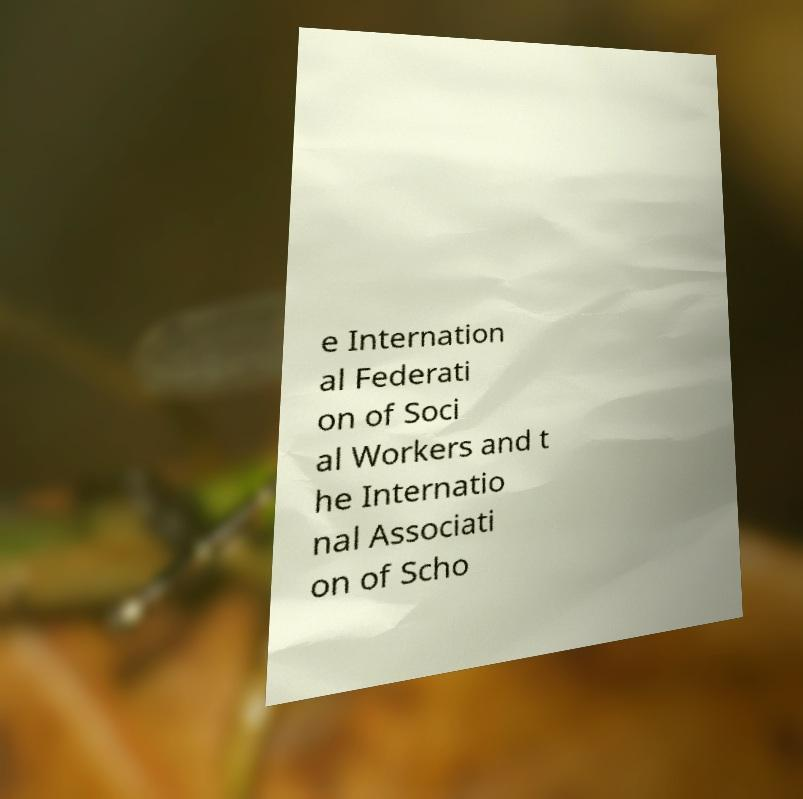There's text embedded in this image that I need extracted. Can you transcribe it verbatim? e Internation al Federati on of Soci al Workers and t he Internatio nal Associati on of Scho 